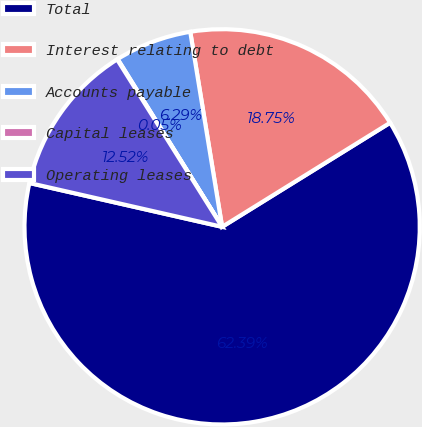<chart> <loc_0><loc_0><loc_500><loc_500><pie_chart><fcel>Total<fcel>Interest relating to debt<fcel>Accounts payable<fcel>Capital leases<fcel>Operating leases<nl><fcel>62.39%<fcel>18.75%<fcel>6.29%<fcel>0.05%<fcel>12.52%<nl></chart> 